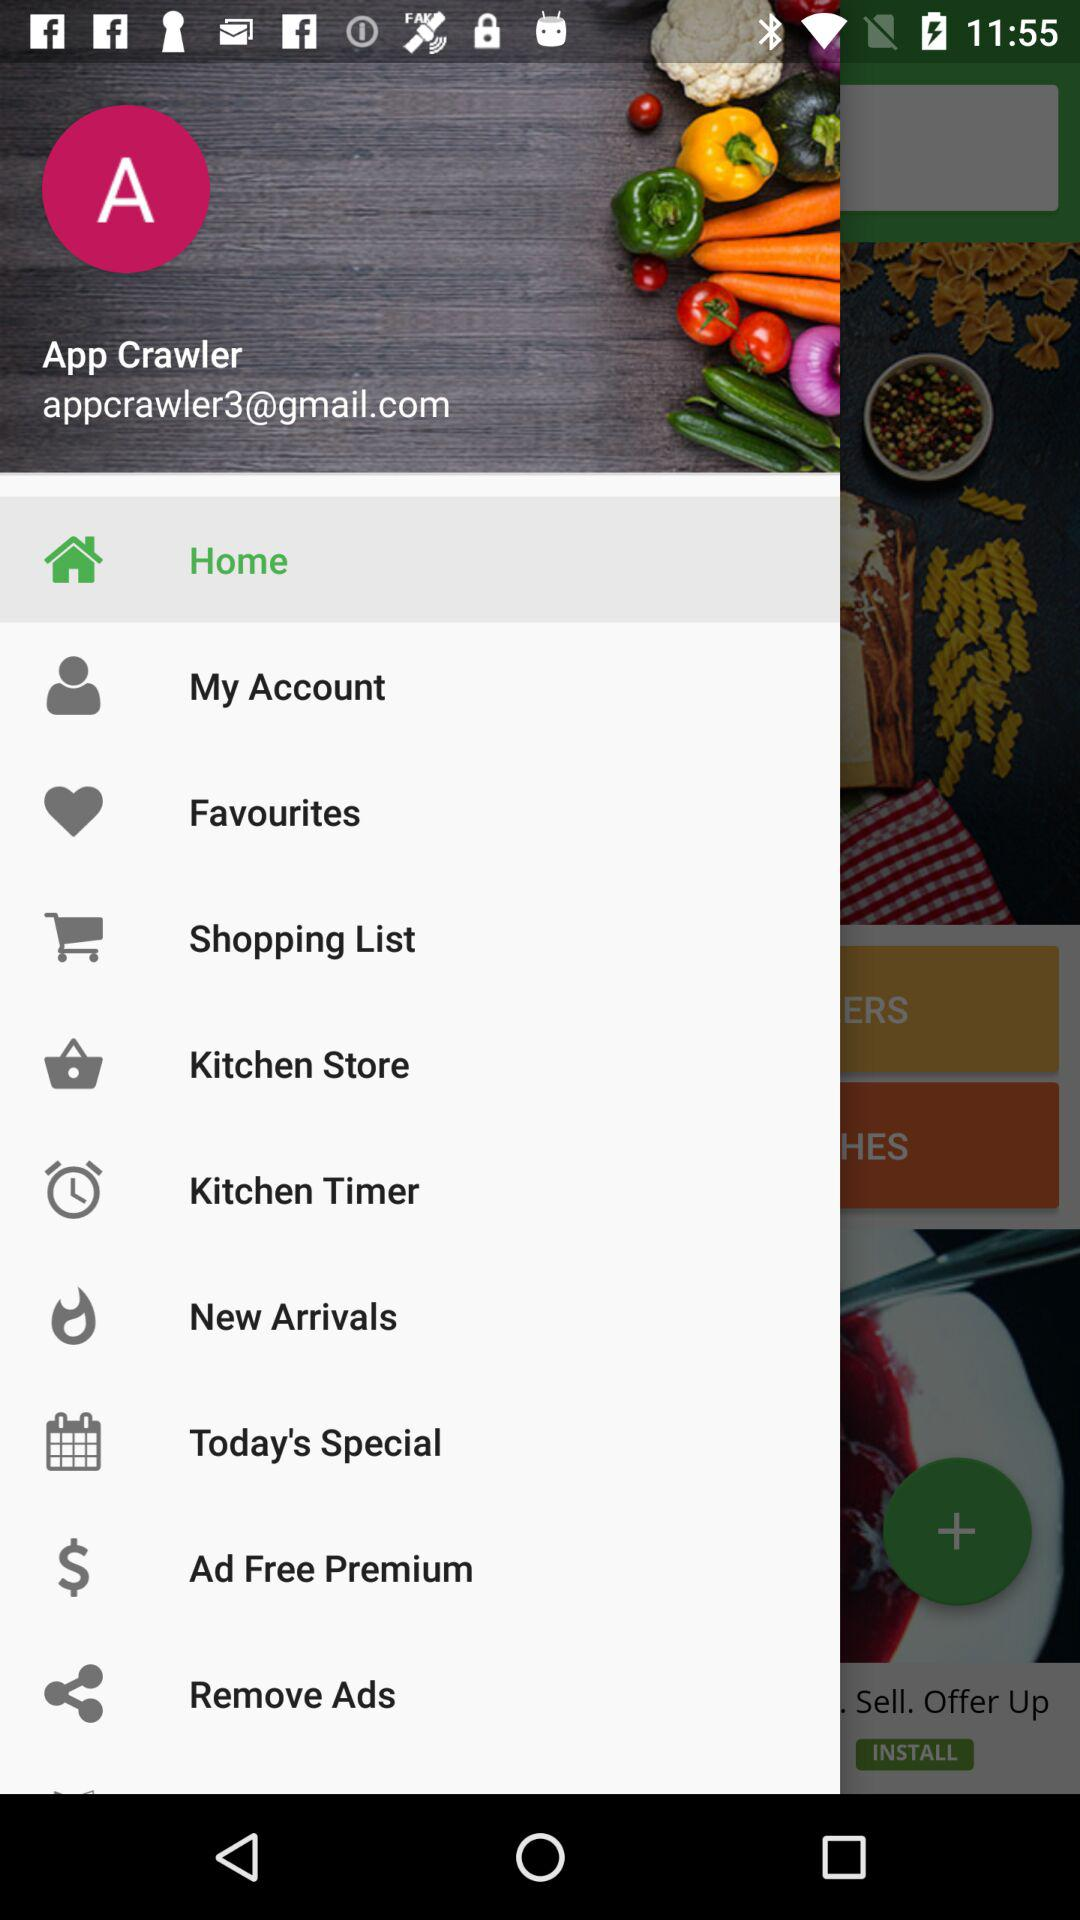What is the user name? The user name is App Crawler. 